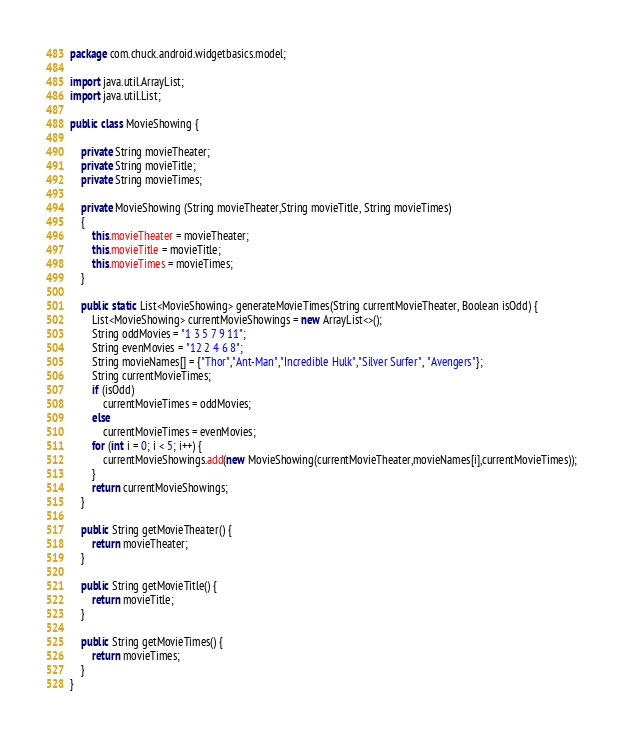<code> <loc_0><loc_0><loc_500><loc_500><_Java_>package com.chuck.android.widgetbasics.model;

import java.util.ArrayList;
import java.util.List;

public class MovieShowing {

    private String movieTheater;
    private String movieTitle;
    private String movieTimes;

    private MovieShowing (String movieTheater,String movieTitle, String movieTimes)
    {
        this.movieTheater = movieTheater;
        this.movieTitle = movieTitle;
        this.movieTimes = movieTimes;
    }

    public static List<MovieShowing> generateMovieTimes(String currentMovieTheater, Boolean isOdd) {
        List<MovieShowing> currentMovieShowings = new ArrayList<>();
        String oddMovies = "1 3 5 7 9 11";
        String evenMovies = "12 2 4 6 8";
        String movieNames[] = {"Thor","Ant-Man","Incredible Hulk","Silver Surfer", "Avengers"};
        String currentMovieTimes;
        if (isOdd)
            currentMovieTimes = oddMovies;
        else
            currentMovieTimes = evenMovies;
        for (int i = 0; i < 5; i++) {
            currentMovieShowings.add(new MovieShowing(currentMovieTheater,movieNames[i],currentMovieTimes));
        }
        return currentMovieShowings;
    }

    public String getMovieTheater() {
        return movieTheater;
    }

    public String getMovieTitle() {
        return movieTitle;
    }

    public String getMovieTimes() {
        return movieTimes;
    }
}
</code> 